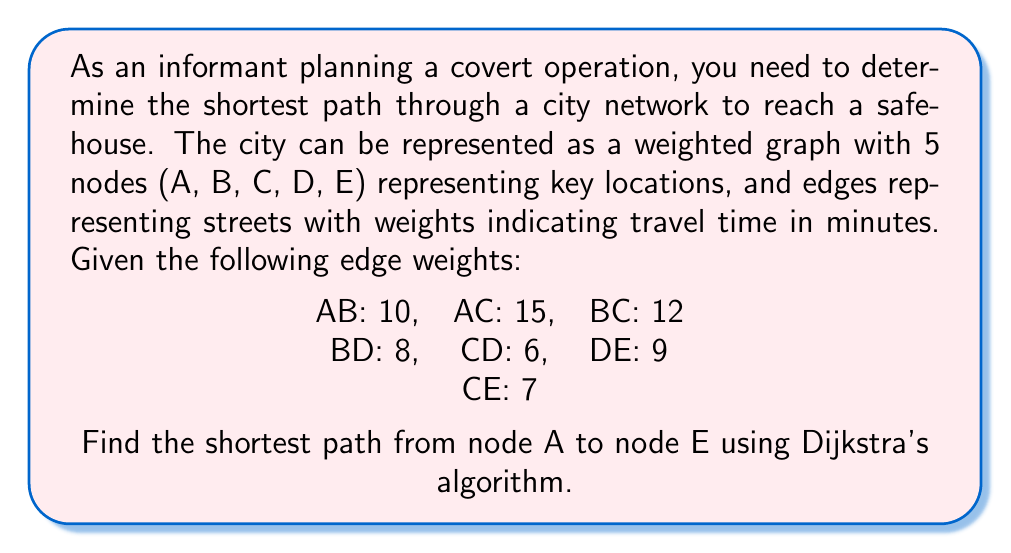Show me your answer to this math problem. Let's apply Dijkstra's algorithm to find the shortest path from A to E:

1) Initialize:
   - Distance to A: 0
   - Distance to all other nodes: $\infty$
   - Set of unvisited nodes: {A, B, C, D, E}

2) Start from node A:
   - Update distances: A->B: 10, A->C: 15
   - Mark A as visited
   - Unvisited: {B, C, D, E}

3) Select B (shortest distance from A):
   - Update distances: B->D: 10 + 8 = 18
   - Mark B as visited
   - Unvisited: {C, D, E}

4) Select C (next shortest from A):
   - Update distances: C->D: min(18, 15 + 6) = 21, C->E: 15 + 7 = 22
   - Mark C as visited
   - Unvisited: {D, E}

5) Select D (next shortest):
   - Update distances: D->E: min(22, 18 + 9) = 22
   - Mark D as visited
   - Unvisited: {E}

6) Select E (only remaining node):
   - Mark E as visited
   - Algorithm complete

The shortest path from A to E is A -> C -> E with a total distance of 22 minutes.

[asy]
unitsize(30);
pair A = (0,0), B = (2,1), C = (1,-2), D = (3,-1), E = (4,-3);
draw(A--B,Arrow);
draw(A--C,Arrow);
draw(B--C,Arrow);
draw(B--D,Arrow);
draw(C--D,Arrow);
draw(D--E,Arrow);
draw(C--E,Arrow);
dot(A); dot(B); dot(C); dot(D); dot(E);
label("A", A, W);
label("B", B, N);
label("C", C, SW);
label("D", D, E);
label("E", E, SE);
label("10", (A+B)/2, NW);
label("15", (A+C)/2, W);
label("12", (B+C)/2, E);
label("8", (B+D)/2, N);
label("6", (C+D)/2, SE);
label("9", (D+E)/2, E);
label("7", (C+E)/2, S);
[/asy]
Answer: A -> C -> E, 22 minutes 